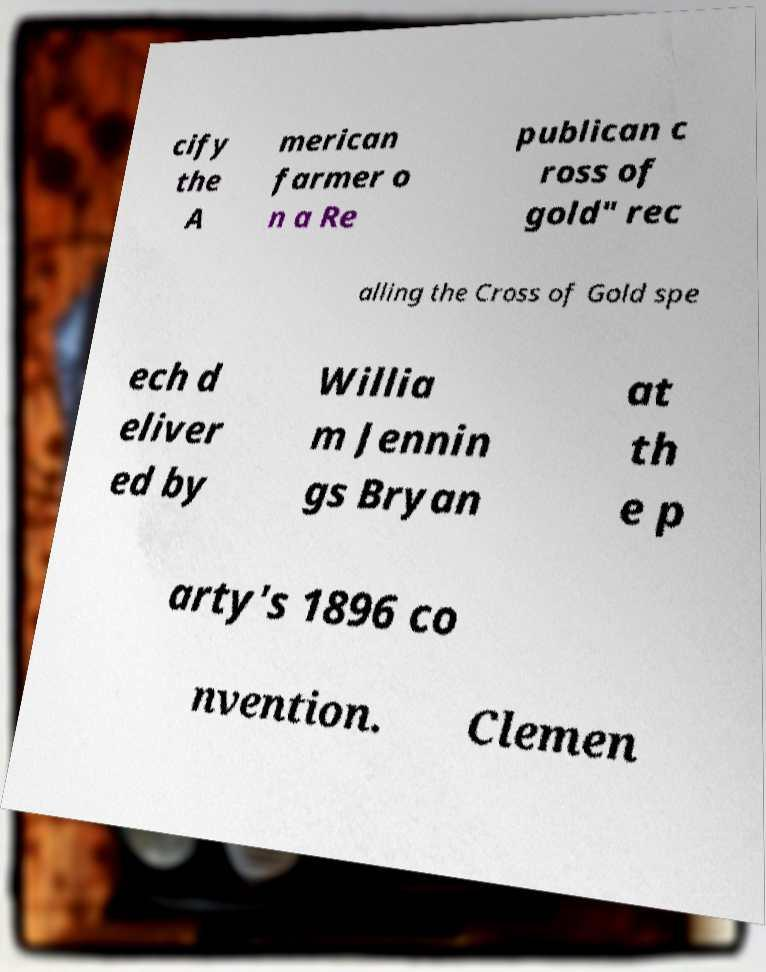Please identify and transcribe the text found in this image. cify the A merican farmer o n a Re publican c ross of gold" rec alling the Cross of Gold spe ech d eliver ed by Willia m Jennin gs Bryan at th e p arty's 1896 co nvention. Clemen 